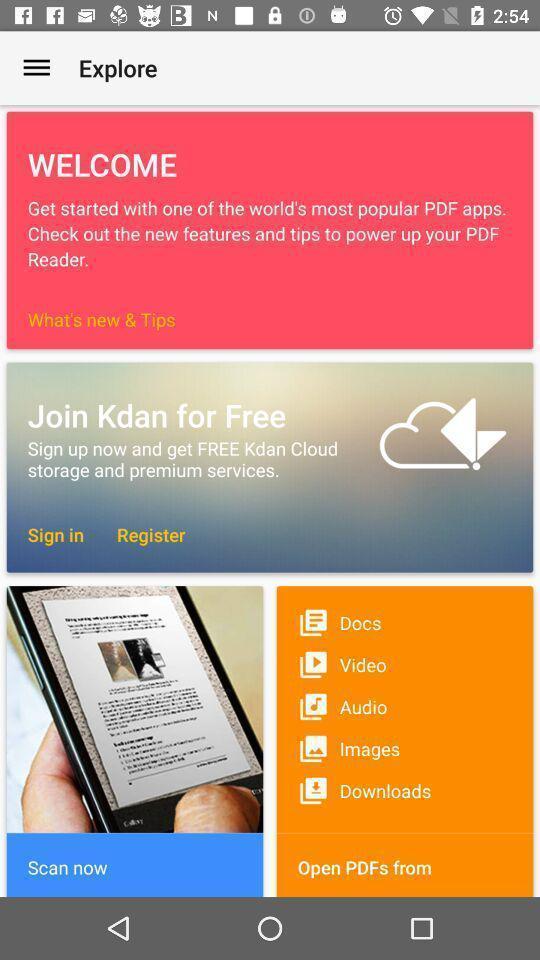Tell me about the visual elements in this screen capture. Welcome page. 